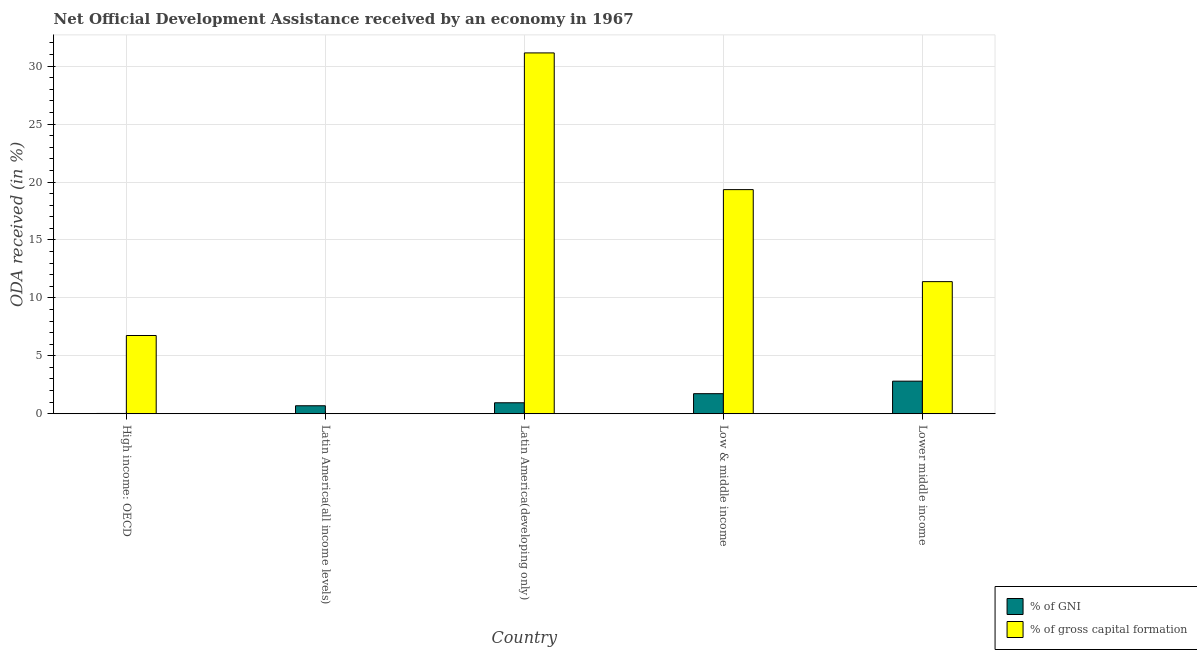Are the number of bars per tick equal to the number of legend labels?
Provide a short and direct response. Yes. Are the number of bars on each tick of the X-axis equal?
Offer a terse response. Yes. How many bars are there on the 1st tick from the left?
Provide a short and direct response. 2. What is the label of the 1st group of bars from the left?
Provide a succinct answer. High income: OECD. In how many cases, is the number of bars for a given country not equal to the number of legend labels?
Ensure brevity in your answer.  0. What is the oda received as percentage of gross capital formation in High income: OECD?
Give a very brief answer. 6.75. Across all countries, what is the maximum oda received as percentage of gni?
Make the answer very short. 2.81. Across all countries, what is the minimum oda received as percentage of gni?
Provide a succinct answer. 0.02. In which country was the oda received as percentage of gni maximum?
Your response must be concise. Lower middle income. In which country was the oda received as percentage of gni minimum?
Provide a succinct answer. High income: OECD. What is the total oda received as percentage of gni in the graph?
Offer a very short reply. 6.2. What is the difference between the oda received as percentage of gni in Latin America(all income levels) and that in Low & middle income?
Provide a succinct answer. -1.04. What is the difference between the oda received as percentage of gross capital formation in Latin America(developing only) and the oda received as percentage of gni in Low & middle income?
Offer a terse response. 29.41. What is the average oda received as percentage of gross capital formation per country?
Offer a terse response. 13.73. What is the difference between the oda received as percentage of gross capital formation and oda received as percentage of gni in Latin America(developing only)?
Provide a succinct answer. 30.2. What is the ratio of the oda received as percentage of gni in High income: OECD to that in Latin America(all income levels)?
Give a very brief answer. 0.04. What is the difference between the highest and the second highest oda received as percentage of gni?
Your answer should be compact. 1.08. What is the difference between the highest and the lowest oda received as percentage of gni?
Your response must be concise. 2.79. Is the sum of the oda received as percentage of gni in Low & middle income and Lower middle income greater than the maximum oda received as percentage of gross capital formation across all countries?
Your answer should be compact. No. What does the 2nd bar from the left in Lower middle income represents?
Offer a very short reply. % of gross capital formation. What does the 1st bar from the right in Lower middle income represents?
Provide a succinct answer. % of gross capital formation. How many bars are there?
Provide a short and direct response. 10. How many countries are there in the graph?
Your answer should be compact. 5. Does the graph contain any zero values?
Give a very brief answer. No. Where does the legend appear in the graph?
Your answer should be compact. Bottom right. How many legend labels are there?
Your answer should be very brief. 2. How are the legend labels stacked?
Offer a terse response. Vertical. What is the title of the graph?
Your answer should be compact. Net Official Development Assistance received by an economy in 1967. Does "Food" appear as one of the legend labels in the graph?
Your answer should be very brief. No. What is the label or title of the Y-axis?
Give a very brief answer. ODA received (in %). What is the ODA received (in %) in % of GNI in High income: OECD?
Ensure brevity in your answer.  0.02. What is the ODA received (in %) of % of gross capital formation in High income: OECD?
Provide a succinct answer. 6.75. What is the ODA received (in %) of % of GNI in Latin America(all income levels)?
Offer a very short reply. 0.69. What is the ODA received (in %) of % of gross capital formation in Latin America(all income levels)?
Ensure brevity in your answer.  2.78176761665473e-5. What is the ODA received (in %) in % of GNI in Latin America(developing only)?
Make the answer very short. 0.95. What is the ODA received (in %) of % of gross capital formation in Latin America(developing only)?
Give a very brief answer. 31.14. What is the ODA received (in %) of % of GNI in Low & middle income?
Provide a succinct answer. 1.73. What is the ODA received (in %) in % of gross capital formation in Low & middle income?
Give a very brief answer. 19.34. What is the ODA received (in %) of % of GNI in Lower middle income?
Ensure brevity in your answer.  2.81. What is the ODA received (in %) in % of gross capital formation in Lower middle income?
Offer a very short reply. 11.4. Across all countries, what is the maximum ODA received (in %) of % of GNI?
Make the answer very short. 2.81. Across all countries, what is the maximum ODA received (in %) in % of gross capital formation?
Ensure brevity in your answer.  31.14. Across all countries, what is the minimum ODA received (in %) in % of GNI?
Provide a short and direct response. 0.02. Across all countries, what is the minimum ODA received (in %) in % of gross capital formation?
Your response must be concise. 2.78176761665473e-5. What is the total ODA received (in %) in % of GNI in the graph?
Your response must be concise. 6.2. What is the total ODA received (in %) in % of gross capital formation in the graph?
Make the answer very short. 68.64. What is the difference between the ODA received (in %) in % of GNI in High income: OECD and that in Latin America(all income levels)?
Ensure brevity in your answer.  -0.66. What is the difference between the ODA received (in %) in % of gross capital formation in High income: OECD and that in Latin America(all income levels)?
Keep it short and to the point. 6.75. What is the difference between the ODA received (in %) in % of GNI in High income: OECD and that in Latin America(developing only)?
Your answer should be very brief. -0.92. What is the difference between the ODA received (in %) in % of gross capital formation in High income: OECD and that in Latin America(developing only)?
Your answer should be compact. -24.39. What is the difference between the ODA received (in %) in % of GNI in High income: OECD and that in Low & middle income?
Your answer should be very brief. -1.71. What is the difference between the ODA received (in %) of % of gross capital formation in High income: OECD and that in Low & middle income?
Keep it short and to the point. -12.59. What is the difference between the ODA received (in %) in % of GNI in High income: OECD and that in Lower middle income?
Give a very brief answer. -2.79. What is the difference between the ODA received (in %) in % of gross capital formation in High income: OECD and that in Lower middle income?
Make the answer very short. -4.65. What is the difference between the ODA received (in %) in % of GNI in Latin America(all income levels) and that in Latin America(developing only)?
Make the answer very short. -0.26. What is the difference between the ODA received (in %) in % of gross capital formation in Latin America(all income levels) and that in Latin America(developing only)?
Ensure brevity in your answer.  -31.14. What is the difference between the ODA received (in %) in % of GNI in Latin America(all income levels) and that in Low & middle income?
Offer a very short reply. -1.04. What is the difference between the ODA received (in %) in % of gross capital formation in Latin America(all income levels) and that in Low & middle income?
Make the answer very short. -19.34. What is the difference between the ODA received (in %) of % of GNI in Latin America(all income levels) and that in Lower middle income?
Provide a short and direct response. -2.12. What is the difference between the ODA received (in %) of % of gross capital formation in Latin America(all income levels) and that in Lower middle income?
Ensure brevity in your answer.  -11.4. What is the difference between the ODA received (in %) of % of GNI in Latin America(developing only) and that in Low & middle income?
Give a very brief answer. -0.79. What is the difference between the ODA received (in %) in % of gross capital formation in Latin America(developing only) and that in Low & middle income?
Your answer should be very brief. 11.8. What is the difference between the ODA received (in %) in % of GNI in Latin America(developing only) and that in Lower middle income?
Keep it short and to the point. -1.87. What is the difference between the ODA received (in %) of % of gross capital formation in Latin America(developing only) and that in Lower middle income?
Ensure brevity in your answer.  19.74. What is the difference between the ODA received (in %) of % of GNI in Low & middle income and that in Lower middle income?
Keep it short and to the point. -1.08. What is the difference between the ODA received (in %) of % of gross capital formation in Low & middle income and that in Lower middle income?
Your response must be concise. 7.94. What is the difference between the ODA received (in %) of % of GNI in High income: OECD and the ODA received (in %) of % of gross capital formation in Latin America(all income levels)?
Provide a short and direct response. 0.02. What is the difference between the ODA received (in %) of % of GNI in High income: OECD and the ODA received (in %) of % of gross capital formation in Latin America(developing only)?
Ensure brevity in your answer.  -31.12. What is the difference between the ODA received (in %) of % of GNI in High income: OECD and the ODA received (in %) of % of gross capital formation in Low & middle income?
Make the answer very short. -19.32. What is the difference between the ODA received (in %) in % of GNI in High income: OECD and the ODA received (in %) in % of gross capital formation in Lower middle income?
Provide a succinct answer. -11.38. What is the difference between the ODA received (in %) in % of GNI in Latin America(all income levels) and the ODA received (in %) in % of gross capital formation in Latin America(developing only)?
Keep it short and to the point. -30.45. What is the difference between the ODA received (in %) in % of GNI in Latin America(all income levels) and the ODA received (in %) in % of gross capital formation in Low & middle income?
Offer a very short reply. -18.65. What is the difference between the ODA received (in %) of % of GNI in Latin America(all income levels) and the ODA received (in %) of % of gross capital formation in Lower middle income?
Keep it short and to the point. -10.71. What is the difference between the ODA received (in %) of % of GNI in Latin America(developing only) and the ODA received (in %) of % of gross capital formation in Low & middle income?
Make the answer very short. -18.4. What is the difference between the ODA received (in %) of % of GNI in Latin America(developing only) and the ODA received (in %) of % of gross capital formation in Lower middle income?
Your response must be concise. -10.46. What is the difference between the ODA received (in %) of % of GNI in Low & middle income and the ODA received (in %) of % of gross capital formation in Lower middle income?
Your response must be concise. -9.67. What is the average ODA received (in %) of % of GNI per country?
Provide a short and direct response. 1.24. What is the average ODA received (in %) in % of gross capital formation per country?
Provide a short and direct response. 13.73. What is the difference between the ODA received (in %) of % of GNI and ODA received (in %) of % of gross capital formation in High income: OECD?
Provide a short and direct response. -6.73. What is the difference between the ODA received (in %) in % of GNI and ODA received (in %) in % of gross capital formation in Latin America(all income levels)?
Keep it short and to the point. 0.69. What is the difference between the ODA received (in %) in % of GNI and ODA received (in %) in % of gross capital formation in Latin America(developing only)?
Your answer should be compact. -30.2. What is the difference between the ODA received (in %) of % of GNI and ODA received (in %) of % of gross capital formation in Low & middle income?
Your answer should be compact. -17.61. What is the difference between the ODA received (in %) of % of GNI and ODA received (in %) of % of gross capital formation in Lower middle income?
Offer a very short reply. -8.59. What is the ratio of the ODA received (in %) in % of GNI in High income: OECD to that in Latin America(all income levels)?
Provide a short and direct response. 0.04. What is the ratio of the ODA received (in %) of % of gross capital formation in High income: OECD to that in Latin America(all income levels)?
Make the answer very short. 2.43e+05. What is the ratio of the ODA received (in %) of % of GNI in High income: OECD to that in Latin America(developing only)?
Your answer should be very brief. 0.03. What is the ratio of the ODA received (in %) of % of gross capital formation in High income: OECD to that in Latin America(developing only)?
Your response must be concise. 0.22. What is the ratio of the ODA received (in %) of % of GNI in High income: OECD to that in Low & middle income?
Ensure brevity in your answer.  0.01. What is the ratio of the ODA received (in %) in % of gross capital formation in High income: OECD to that in Low & middle income?
Give a very brief answer. 0.35. What is the ratio of the ODA received (in %) of % of GNI in High income: OECD to that in Lower middle income?
Offer a terse response. 0.01. What is the ratio of the ODA received (in %) of % of gross capital formation in High income: OECD to that in Lower middle income?
Give a very brief answer. 0.59. What is the ratio of the ODA received (in %) in % of GNI in Latin America(all income levels) to that in Latin America(developing only)?
Your answer should be compact. 0.73. What is the ratio of the ODA received (in %) in % of gross capital formation in Latin America(all income levels) to that in Latin America(developing only)?
Give a very brief answer. 0. What is the ratio of the ODA received (in %) in % of GNI in Latin America(all income levels) to that in Low & middle income?
Provide a short and direct response. 0.4. What is the ratio of the ODA received (in %) of % of GNI in Latin America(all income levels) to that in Lower middle income?
Offer a very short reply. 0.24. What is the ratio of the ODA received (in %) in % of GNI in Latin America(developing only) to that in Low & middle income?
Offer a very short reply. 0.55. What is the ratio of the ODA received (in %) in % of gross capital formation in Latin America(developing only) to that in Low & middle income?
Offer a terse response. 1.61. What is the ratio of the ODA received (in %) in % of GNI in Latin America(developing only) to that in Lower middle income?
Give a very brief answer. 0.34. What is the ratio of the ODA received (in %) of % of gross capital formation in Latin America(developing only) to that in Lower middle income?
Keep it short and to the point. 2.73. What is the ratio of the ODA received (in %) of % of GNI in Low & middle income to that in Lower middle income?
Make the answer very short. 0.62. What is the ratio of the ODA received (in %) of % of gross capital formation in Low & middle income to that in Lower middle income?
Your answer should be very brief. 1.7. What is the difference between the highest and the second highest ODA received (in %) in % of GNI?
Keep it short and to the point. 1.08. What is the difference between the highest and the second highest ODA received (in %) in % of gross capital formation?
Offer a terse response. 11.8. What is the difference between the highest and the lowest ODA received (in %) in % of GNI?
Your answer should be compact. 2.79. What is the difference between the highest and the lowest ODA received (in %) in % of gross capital formation?
Your response must be concise. 31.14. 